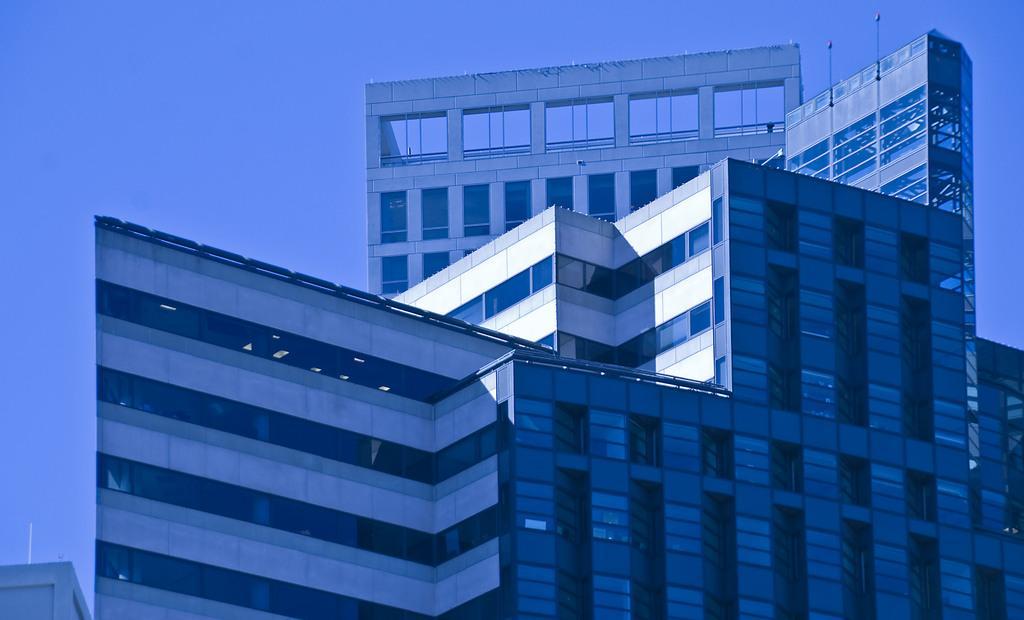In one or two sentences, can you explain what this image depicts? In this picture I can see there is a building and it has some glass windows and the sky is clear. 